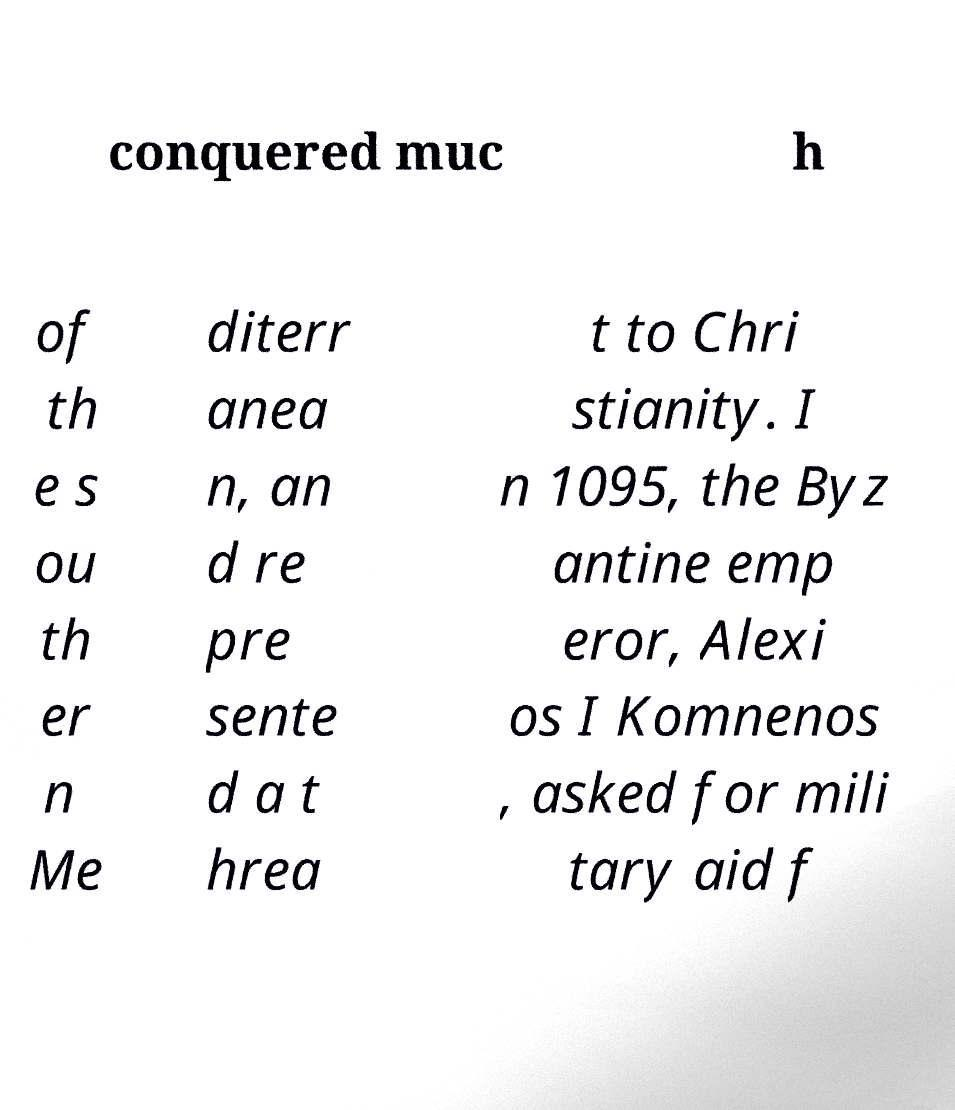Please read and relay the text visible in this image. What does it say? conquered muc h of th e s ou th er n Me diterr anea n, an d re pre sente d a t hrea t to Chri stianity. I n 1095, the Byz antine emp eror, Alexi os I Komnenos , asked for mili tary aid f 